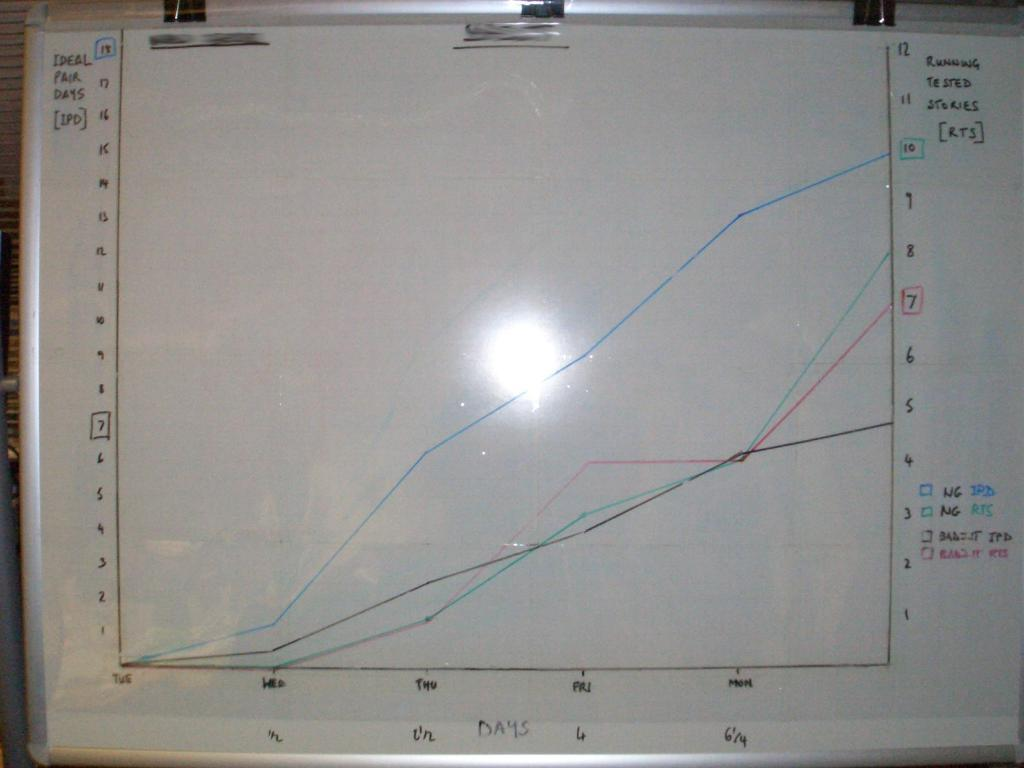<image>
Provide a brief description of the given image. A graph is depicted on white board with "Days" as the x-axis and "Ideal Pair Days" as the y-axis. 